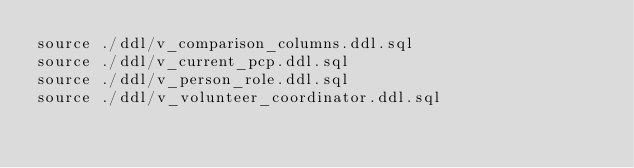Convert code to text. <code><loc_0><loc_0><loc_500><loc_500><_SQL_>source ./ddl/v_comparison_columns.ddl.sql
source ./ddl/v_current_pcp.ddl.sql
source ./ddl/v_person_role.ddl.sql
source ./ddl/v_volunteer_coordinator.ddl.sql
</code> 